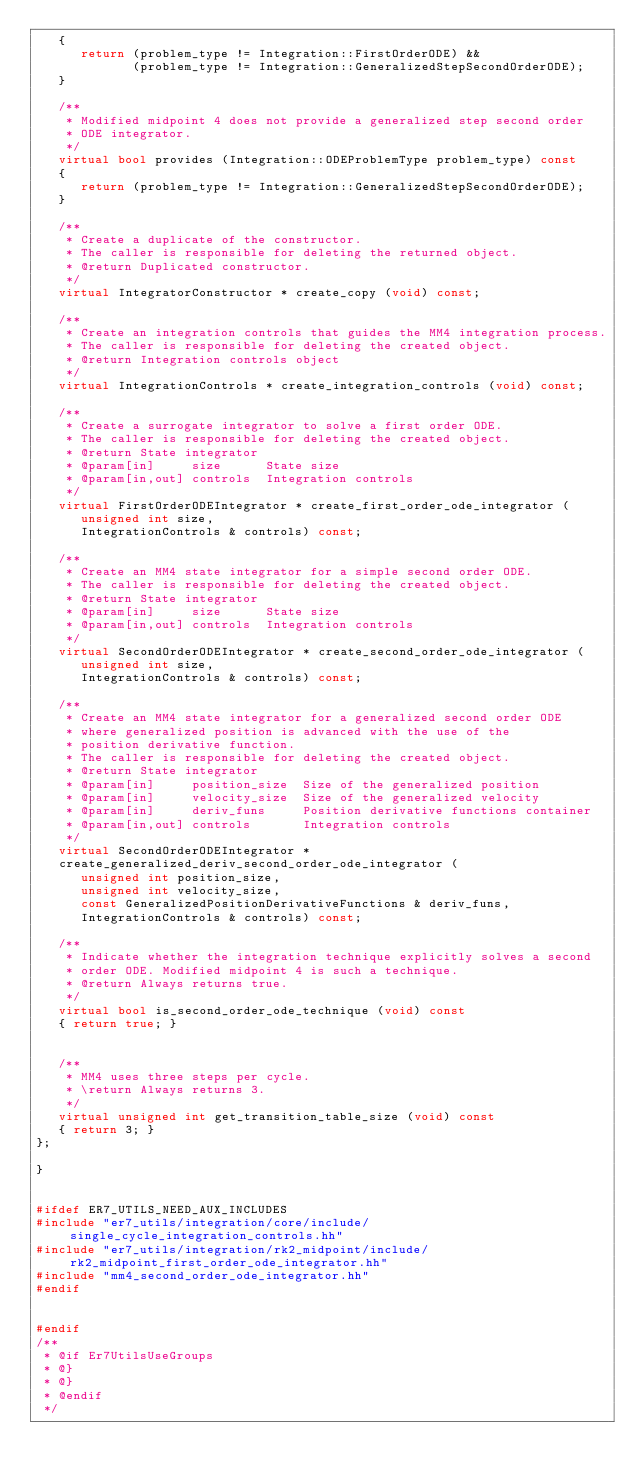<code> <loc_0><loc_0><loc_500><loc_500><_C++_>   {
      return (problem_type != Integration::FirstOrderODE) &&
             (problem_type != Integration::GeneralizedStepSecondOrderODE);
   }

   /**
    * Modified midpoint 4 does not provide a generalized step second order
    * ODE integrator.
    */
   virtual bool provides (Integration::ODEProblemType problem_type) const
   {
      return (problem_type != Integration::GeneralizedStepSecondOrderODE);
   }

   /**
    * Create a duplicate of the constructor.
    * The caller is responsible for deleting the returned object.
    * @return Duplicated constructor.
    */
   virtual IntegratorConstructor * create_copy (void) const;

   /**
    * Create an integration controls that guides the MM4 integration process.
    * The caller is responsible for deleting the created object.
    * @return Integration controls object
    */
   virtual IntegrationControls * create_integration_controls (void) const;

   /**
    * Create a surrogate integrator to solve a first order ODE.
    * The caller is responsible for deleting the created object.
    * @return State integrator
    * @param[in]     size      State size
    * @param[in,out] controls  Integration controls
    */
   virtual FirstOrderODEIntegrator * create_first_order_ode_integrator (
      unsigned int size,
      IntegrationControls & controls) const;

   /**
    * Create an MM4 state integrator for a simple second order ODE.
    * The caller is responsible for deleting the created object.
    * @return State integrator
    * @param[in]     size      State size
    * @param[in,out] controls  Integration controls
    */
   virtual SecondOrderODEIntegrator * create_second_order_ode_integrator (
      unsigned int size,
      IntegrationControls & controls) const;

   /**
    * Create an MM4 state integrator for a generalized second order ODE
    * where generalized position is advanced with the use of the
    * position derivative function.
    * The caller is responsible for deleting the created object.
    * @return State integrator
    * @param[in]     position_size  Size of the generalized position
    * @param[in]     velocity_size  Size of the generalized velocity
    * @param[in]     deriv_funs     Position derivative functions container
    * @param[in,out] controls       Integration controls
    */
   virtual SecondOrderODEIntegrator *
   create_generalized_deriv_second_order_ode_integrator (
      unsigned int position_size,
      unsigned int velocity_size,
      const GeneralizedPositionDerivativeFunctions & deriv_funs,
      IntegrationControls & controls) const;

   /**
    * Indicate whether the integration technique explicitly solves a second
    * order ODE. Modified midpoint 4 is such a technique.
    * @return Always returns true.
    */
   virtual bool is_second_order_ode_technique (void) const
   { return true; }


   /**
    * MM4 uses three steps per cycle.
    * \return Always returns 3.
    */
   virtual unsigned int get_transition_table_size (void) const
   { return 3; }
};

}


#ifdef ER7_UTILS_NEED_AUX_INCLUDES
#include "er7_utils/integration/core/include/single_cycle_integration_controls.hh"
#include "er7_utils/integration/rk2_midpoint/include/rk2_midpoint_first_order_ode_integrator.hh"
#include "mm4_second_order_ode_integrator.hh"
#endif


#endif
/**
 * @if Er7UtilsUseGroups
 * @}
 * @}
 * @endif
 */
</code> 